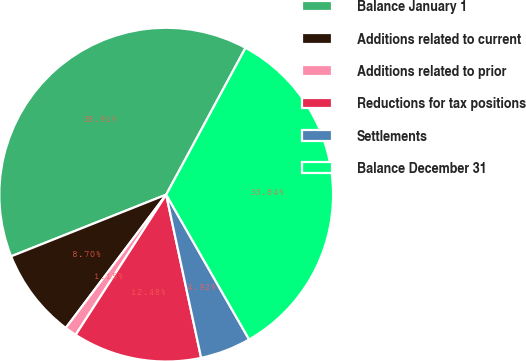Convert chart to OTSL. <chart><loc_0><loc_0><loc_500><loc_500><pie_chart><fcel>Balance January 1<fcel>Additions related to current<fcel>Additions related to prior<fcel>Reductions for tax positions<fcel>Settlements<fcel>Balance December 31<nl><fcel>38.91%<fcel>8.7%<fcel>1.15%<fcel>12.48%<fcel>4.92%<fcel>33.84%<nl></chart> 